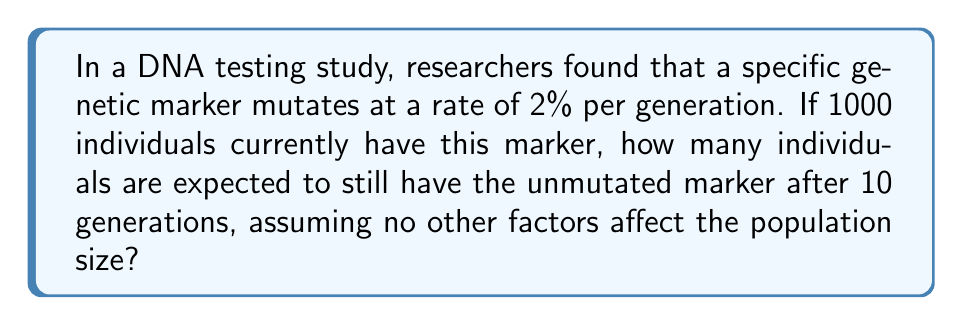Show me your answer to this math problem. To solve this problem, we need to use an exponential decay function. The rate of decay (mutation) is 2% per generation, which means 98% of the marker remains unchanged each generation.

Let's define our variables:
$N_0$ = initial number of individuals with the unmutated marker (1000)
$r$ = rate of decay per generation (0.98, as 98% remains unchanged)
$t$ = number of generations (10)
$N$ = number of individuals with unmutated marker after $t$ generations

The exponential decay formula is:

$$N = N_0 \cdot r^t$$

Plugging in our values:

$$N = 1000 \cdot (0.98)^{10}$$

Now, let's calculate:

$$\begin{align}
N &= 1000 \cdot (0.98)^{10} \\
&= 1000 \cdot 0.8171461884 \\
&\approx 817.15
\end{align}$$

Since we're dealing with whole individuals, we round down to the nearest whole number.
Answer: 817 individuals 